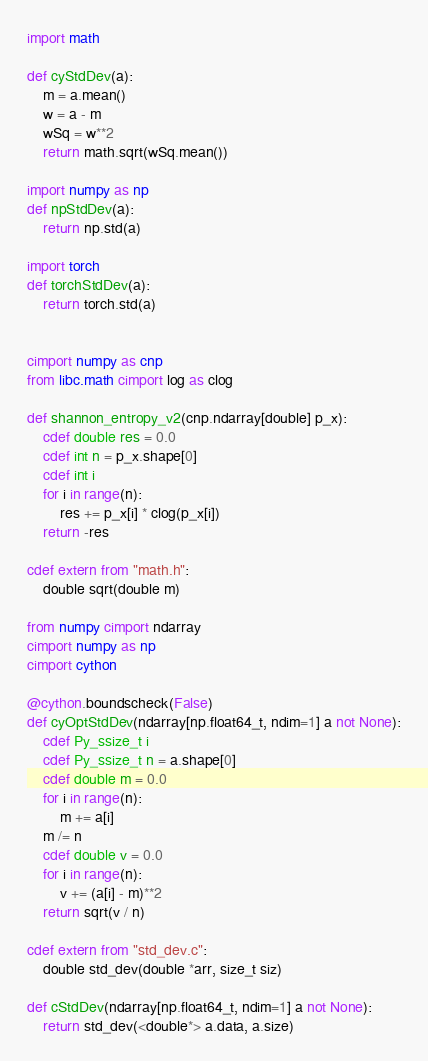Convert code to text. <code><loc_0><loc_0><loc_500><loc_500><_Cython_>import math

def cyStdDev(a):
    m = a.mean()
    w = a - m
    wSq = w**2
    return math.sqrt(wSq.mean())

import numpy as np
def npStdDev(a):
    return np.std(a)

import torch
def torchStdDev(a):
    return torch.std(a)


cimport numpy as cnp
from libc.math cimport log as clog

def shannon_entropy_v2(cnp.ndarray[double] p_x):
    cdef double res = 0.0
    cdef int n = p_x.shape[0]
    cdef int i
    for i in range(n):
        res += p_x[i] * clog(p_x[i])
    return -res

cdef extern from "math.h":
    double sqrt(double m)

from numpy cimport ndarray
cimport numpy as np
cimport cython

@cython.boundscheck(False)
def cyOptStdDev(ndarray[np.float64_t, ndim=1] a not None):
    cdef Py_ssize_t i
    cdef Py_ssize_t n = a.shape[0]
    cdef double m = 0.0
    for i in range(n):
        m += a[i]
    m /= n
    cdef double v = 0.0
    for i in range(n):
        v += (a[i] - m)**2
    return sqrt(v / n)

cdef extern from "std_dev.c":
    double std_dev(double *arr, size_t siz)

def cStdDev(ndarray[np.float64_t, ndim=1] a not None):
    return std_dev(<double*> a.data, a.size)</code> 